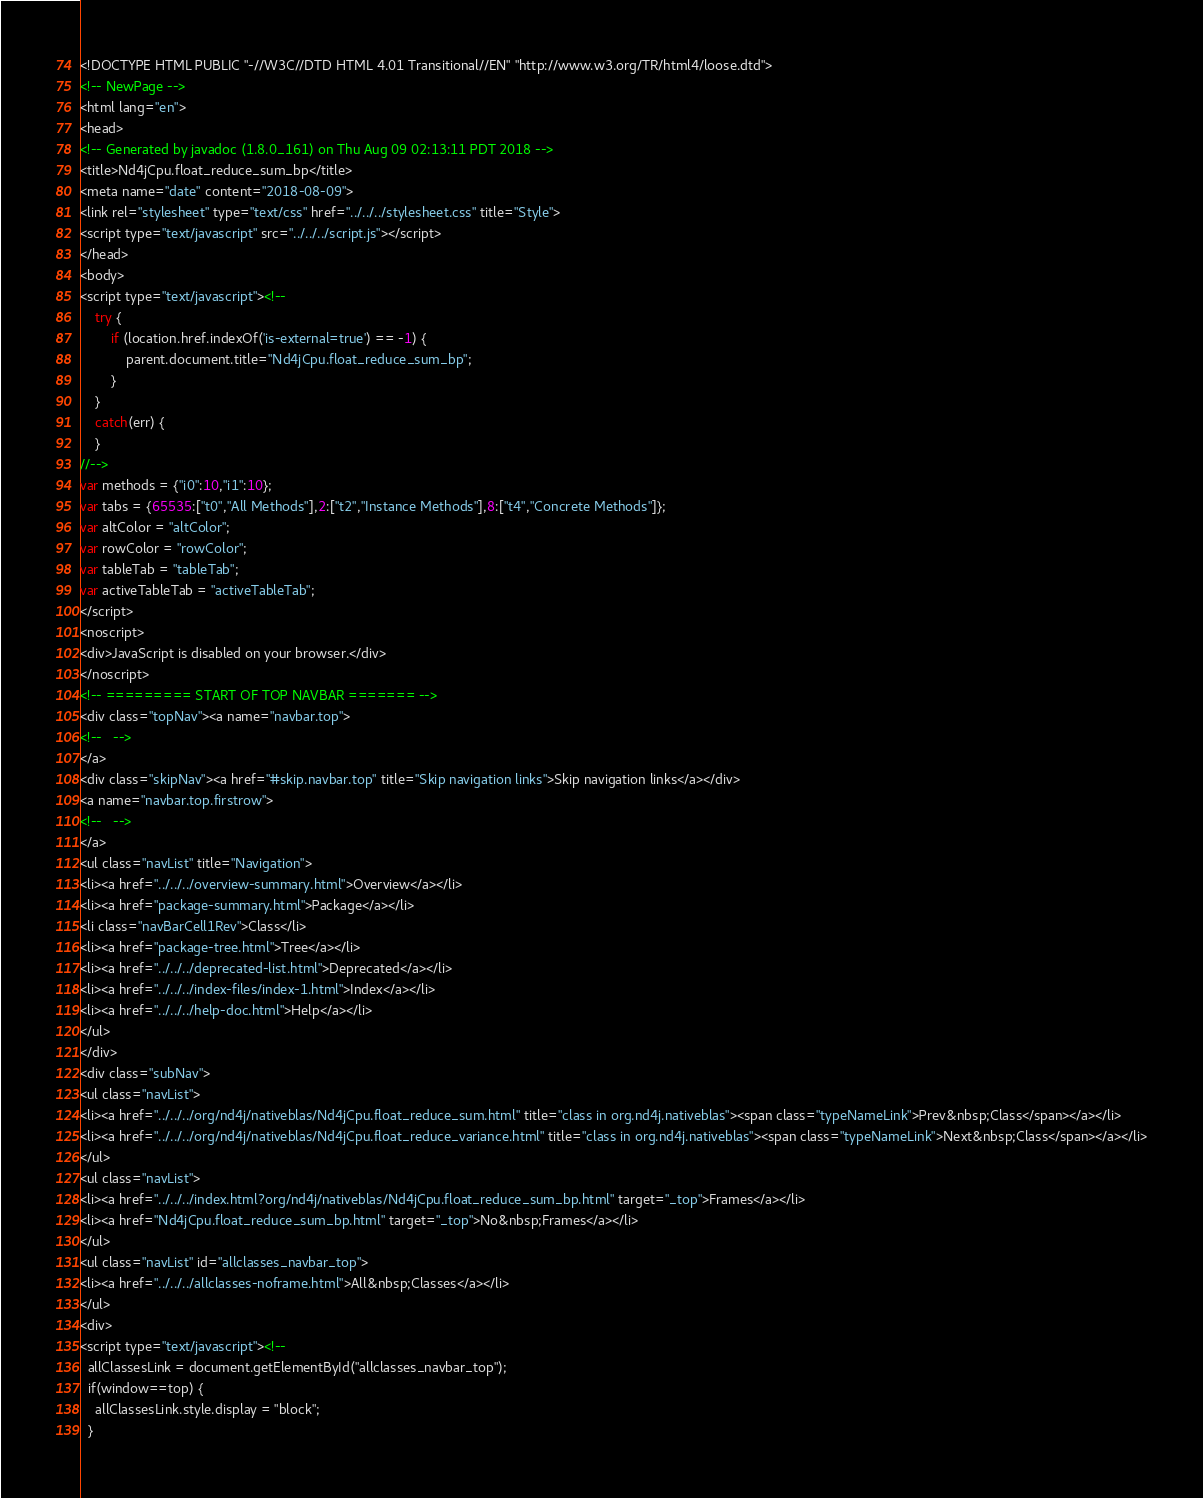Convert code to text. <code><loc_0><loc_0><loc_500><loc_500><_HTML_><!DOCTYPE HTML PUBLIC "-//W3C//DTD HTML 4.01 Transitional//EN" "http://www.w3.org/TR/html4/loose.dtd">
<!-- NewPage -->
<html lang="en">
<head>
<!-- Generated by javadoc (1.8.0_161) on Thu Aug 09 02:13:11 PDT 2018 -->
<title>Nd4jCpu.float_reduce_sum_bp</title>
<meta name="date" content="2018-08-09">
<link rel="stylesheet" type="text/css" href="../../../stylesheet.css" title="Style">
<script type="text/javascript" src="../../../script.js"></script>
</head>
<body>
<script type="text/javascript"><!--
    try {
        if (location.href.indexOf('is-external=true') == -1) {
            parent.document.title="Nd4jCpu.float_reduce_sum_bp";
        }
    }
    catch(err) {
    }
//-->
var methods = {"i0":10,"i1":10};
var tabs = {65535:["t0","All Methods"],2:["t2","Instance Methods"],8:["t4","Concrete Methods"]};
var altColor = "altColor";
var rowColor = "rowColor";
var tableTab = "tableTab";
var activeTableTab = "activeTableTab";
</script>
<noscript>
<div>JavaScript is disabled on your browser.</div>
</noscript>
<!-- ========= START OF TOP NAVBAR ======= -->
<div class="topNav"><a name="navbar.top">
<!--   -->
</a>
<div class="skipNav"><a href="#skip.navbar.top" title="Skip navigation links">Skip navigation links</a></div>
<a name="navbar.top.firstrow">
<!--   -->
</a>
<ul class="navList" title="Navigation">
<li><a href="../../../overview-summary.html">Overview</a></li>
<li><a href="package-summary.html">Package</a></li>
<li class="navBarCell1Rev">Class</li>
<li><a href="package-tree.html">Tree</a></li>
<li><a href="../../../deprecated-list.html">Deprecated</a></li>
<li><a href="../../../index-files/index-1.html">Index</a></li>
<li><a href="../../../help-doc.html">Help</a></li>
</ul>
</div>
<div class="subNav">
<ul class="navList">
<li><a href="../../../org/nd4j/nativeblas/Nd4jCpu.float_reduce_sum.html" title="class in org.nd4j.nativeblas"><span class="typeNameLink">Prev&nbsp;Class</span></a></li>
<li><a href="../../../org/nd4j/nativeblas/Nd4jCpu.float_reduce_variance.html" title="class in org.nd4j.nativeblas"><span class="typeNameLink">Next&nbsp;Class</span></a></li>
</ul>
<ul class="navList">
<li><a href="../../../index.html?org/nd4j/nativeblas/Nd4jCpu.float_reduce_sum_bp.html" target="_top">Frames</a></li>
<li><a href="Nd4jCpu.float_reduce_sum_bp.html" target="_top">No&nbsp;Frames</a></li>
</ul>
<ul class="navList" id="allclasses_navbar_top">
<li><a href="../../../allclasses-noframe.html">All&nbsp;Classes</a></li>
</ul>
<div>
<script type="text/javascript"><!--
  allClassesLink = document.getElementById("allclasses_navbar_top");
  if(window==top) {
    allClassesLink.style.display = "block";
  }</code> 